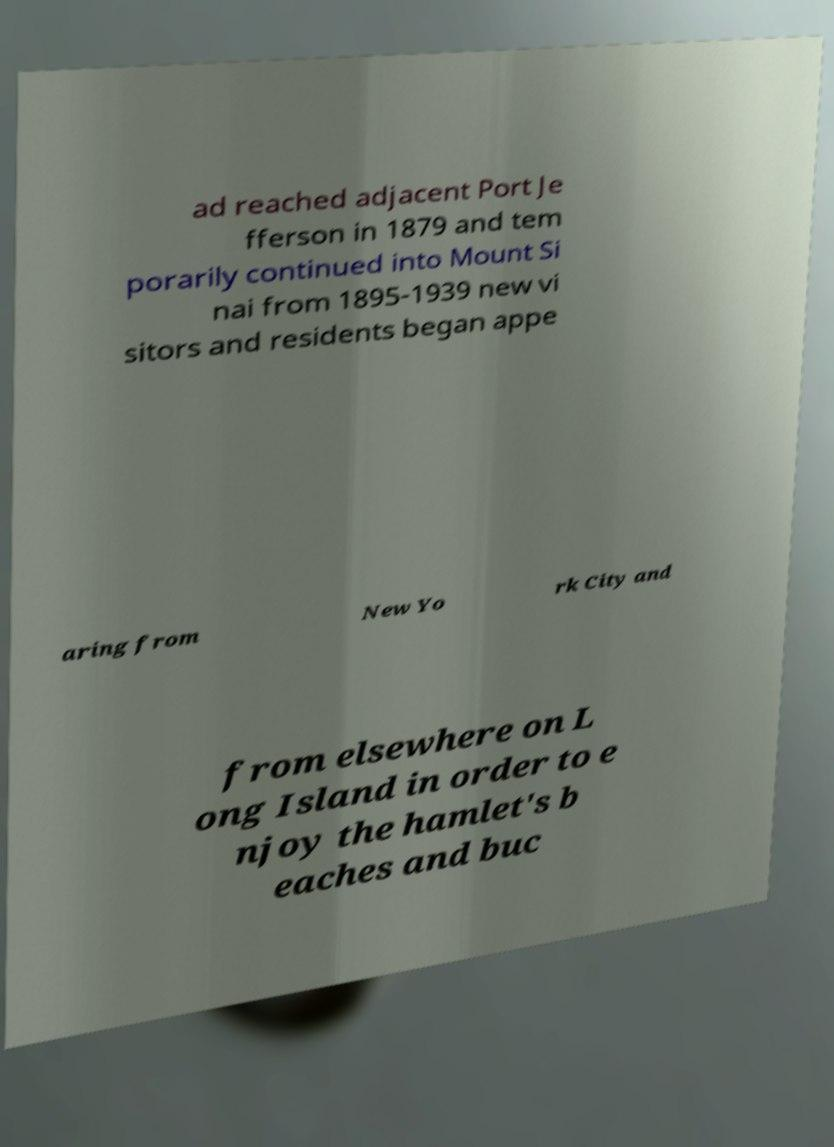Please identify and transcribe the text found in this image. ad reached adjacent Port Je fferson in 1879 and tem porarily continued into Mount Si nai from 1895-1939 new vi sitors and residents began appe aring from New Yo rk City and from elsewhere on L ong Island in order to e njoy the hamlet's b eaches and buc 